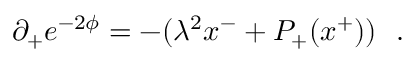<formula> <loc_0><loc_0><loc_500><loc_500>\partial _ { + } e ^ { - 2 \phi } = - ( \lambda ^ { 2 } x ^ { - } + P _ { + } ( x ^ { + } ) ) \ \ .</formula> 